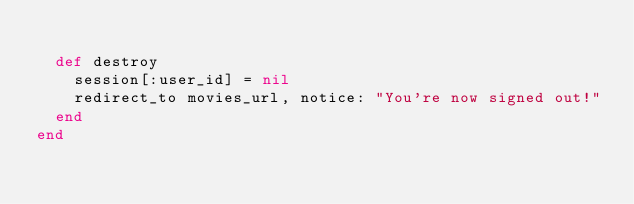<code> <loc_0><loc_0><loc_500><loc_500><_Ruby_>
  def destroy
    session[:user_id] = nil
    redirect_to movies_url, notice: "You're now signed out!"
  end
end
</code> 